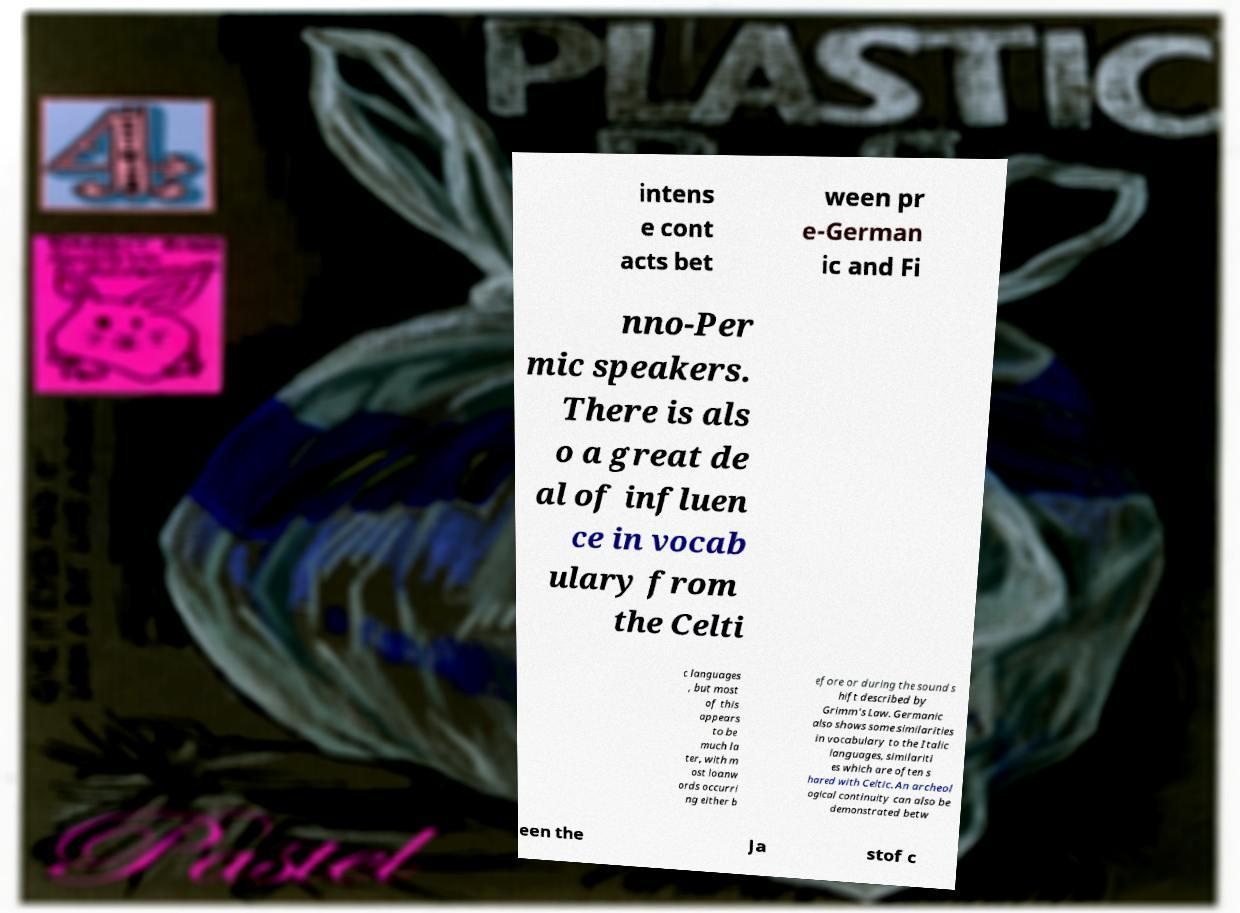Could you extract and type out the text from this image? intens e cont acts bet ween pr e-German ic and Fi nno-Per mic speakers. There is als o a great de al of influen ce in vocab ulary from the Celti c languages , but most of this appears to be much la ter, with m ost loanw ords occurri ng either b efore or during the sound s hift described by Grimm's Law. Germanic also shows some similarities in vocabulary to the Italic languages, similariti es which are often s hared with Celtic. An archeol ogical continuity can also be demonstrated betw een the Ja stof c 